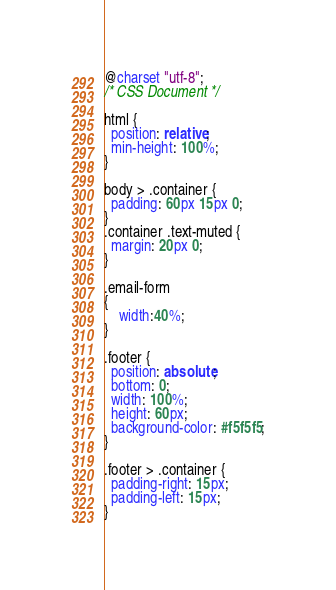Convert code to text. <code><loc_0><loc_0><loc_500><loc_500><_CSS_>@charset "utf-8";
/* CSS Document */

html {
  position: relative;
  min-height: 100%;
}

body > .container {
  padding: 60px 15px 0;
}
.container .text-muted {
  margin: 20px 0;
}

.email-form
{
	width:40%;
}

.footer {
  position: absolute;
  bottom: 0;
  width: 100%;
  height: 60px;
  background-color: #f5f5f5;
}

.footer > .container {
  padding-right: 15px;
  padding-left: 15px;
}
</code> 